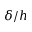Convert formula to latex. <formula><loc_0><loc_0><loc_500><loc_500>\delta / h</formula> 